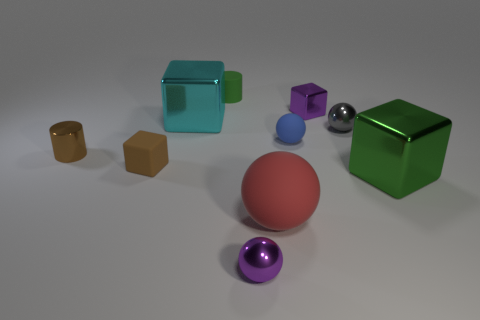The rubber sphere in front of the green thing that is in front of the small green matte thing is what color?
Your answer should be very brief. Red. What number of blue objects are tiny metal spheres or small rubber cylinders?
Provide a succinct answer. 0. There is a tiny rubber object that is in front of the small purple cube and to the right of the brown block; what is its color?
Offer a terse response. Blue. How many big things are metallic blocks or brown rubber objects?
Your answer should be very brief. 2. The gray metal object that is the same shape as the blue matte thing is what size?
Ensure brevity in your answer.  Small. The big green metal object has what shape?
Offer a terse response. Cube. Is the blue ball made of the same material as the purple object that is in front of the small blue rubber thing?
Your answer should be compact. No. What number of shiny objects are tiny objects or large cyan objects?
Your answer should be very brief. 5. What is the size of the cylinder in front of the tiny blue rubber ball?
Offer a terse response. Small. What is the size of the sphere that is the same material as the blue thing?
Your answer should be compact. Large. 